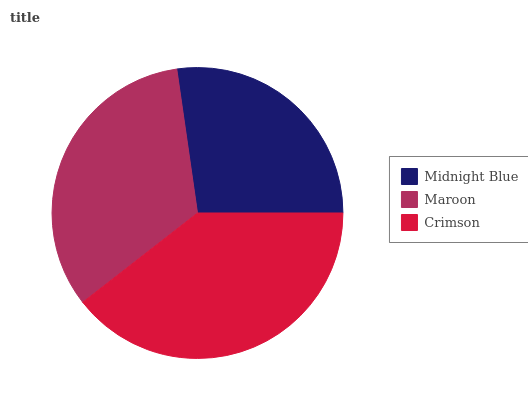Is Midnight Blue the minimum?
Answer yes or no. Yes. Is Crimson the maximum?
Answer yes or no. Yes. Is Maroon the minimum?
Answer yes or no. No. Is Maroon the maximum?
Answer yes or no. No. Is Maroon greater than Midnight Blue?
Answer yes or no. Yes. Is Midnight Blue less than Maroon?
Answer yes or no. Yes. Is Midnight Blue greater than Maroon?
Answer yes or no. No. Is Maroon less than Midnight Blue?
Answer yes or no. No. Is Maroon the high median?
Answer yes or no. Yes. Is Maroon the low median?
Answer yes or no. Yes. Is Midnight Blue the high median?
Answer yes or no. No. Is Midnight Blue the low median?
Answer yes or no. No. 